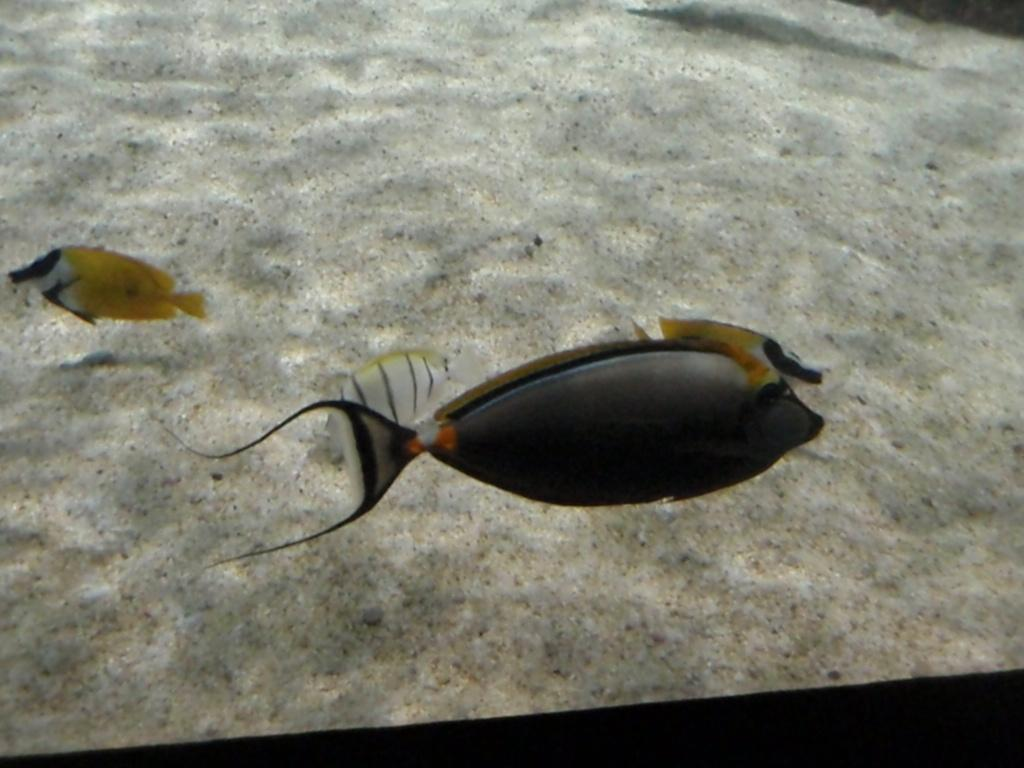What type of environment is depicted in the image? The image features water and sand, suggesting a beach or coastal setting. What creatures can be seen in the water? There are fishes in the image. Can you describe the water in the image? The water is visible in the image, but no specific details about its appearance are provided. What type of locket can be seen hanging from the fishes in the image? There is no locket present in the image; it features water, sand, and fishes. Can you tell me how many cakes are visible in the image? There are no cakes present in the image; it features water, sand, and fishes. 